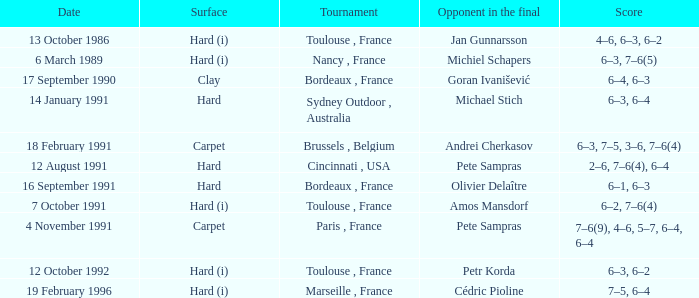What is the date of the tournament with olivier delaître as the opponent in the final? 16 September 1991. 